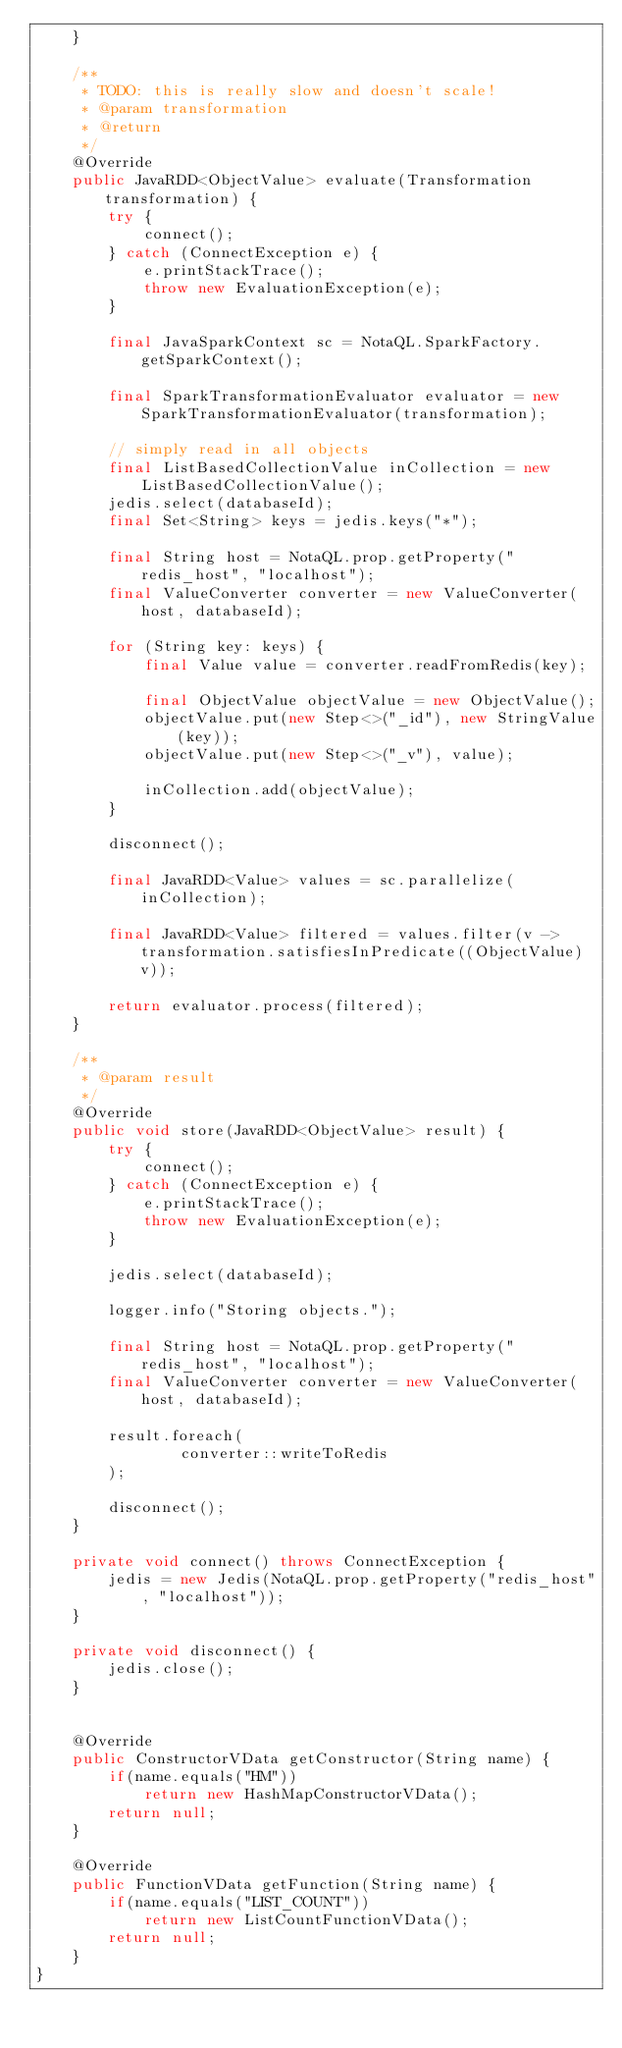<code> <loc_0><loc_0><loc_500><loc_500><_Java_>    }

    /**
     * TODO: this is really slow and doesn't scale!
     * @param transformation
     * @return
     */
    @Override
    public JavaRDD<ObjectValue> evaluate(Transformation transformation) {
        try {
            connect();
        } catch (ConnectException e) {
            e.printStackTrace();
            throw new EvaluationException(e);
        }

        final JavaSparkContext sc = NotaQL.SparkFactory.getSparkContext();

        final SparkTransformationEvaluator evaluator = new SparkTransformationEvaluator(transformation);

        // simply read in all objects
        final ListBasedCollectionValue inCollection = new ListBasedCollectionValue();
        jedis.select(databaseId);
        final Set<String> keys = jedis.keys("*");

        final String host = NotaQL.prop.getProperty("redis_host", "localhost");
        final ValueConverter converter = new ValueConverter(host, databaseId);

        for (String key: keys) {
            final Value value = converter.readFromRedis(key);

            final ObjectValue objectValue = new ObjectValue();
            objectValue.put(new Step<>("_id"), new StringValue(key));
            objectValue.put(new Step<>("_v"), value);

            inCollection.add(objectValue);
        }

        disconnect();

        final JavaRDD<Value> values = sc.parallelize(inCollection);

        final JavaRDD<Value> filtered = values.filter(v -> transformation.satisfiesInPredicate((ObjectValue) v));

        return evaluator.process(filtered);
    }

    /**
     * @param result
     */
    @Override
    public void store(JavaRDD<ObjectValue> result) {
        try {
            connect();
        } catch (ConnectException e) {
            e.printStackTrace();
            throw new EvaluationException(e);
        }

        jedis.select(databaseId);

        logger.info("Storing objects.");

        final String host = NotaQL.prop.getProperty("redis_host", "localhost");
        final ValueConverter converter = new ValueConverter(host, databaseId);

        result.foreach(
                converter::writeToRedis
        );

        disconnect();
    }

    private void connect() throws ConnectException {
        jedis = new Jedis(NotaQL.prop.getProperty("redis_host", "localhost"));
    }

    private void disconnect() {
        jedis.close();
    }


    @Override
    public ConstructorVData getConstructor(String name) {
        if(name.equals("HM"))
            return new HashMapConstructorVData();
        return null;
    }

    @Override
    public FunctionVData getFunction(String name) {
        if(name.equals("LIST_COUNT"))
            return new ListCountFunctionVData();
        return null;
    }
}
</code> 